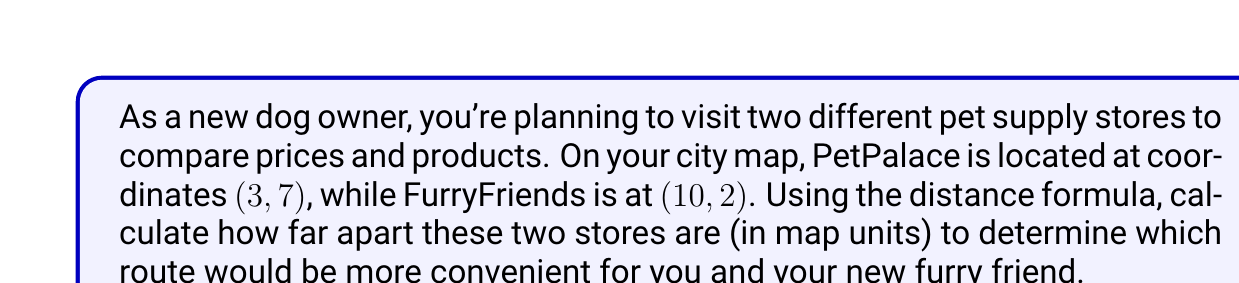Show me your answer to this math problem. To solve this problem, we'll use the distance formula, which is derived from the Pythagorean theorem. The distance formula for two points $(x_1, y_1)$ and $(x_2, y_2)$ is:

$$d = \sqrt{(x_2 - x_1)^2 + (y_2 - y_1)^2}$$

Let's follow these steps:

1. Identify the coordinates:
   PetPalace: $(x_1, y_1) = (3, 7)$
   FurryFriends: $(x_2, y_2) = (10, 2)$

2. Substitute these values into the distance formula:
   $$d = \sqrt{(10 - 3)^2 + (2 - 7)^2}$$

3. Simplify the expressions inside the parentheses:
   $$d = \sqrt{7^2 + (-5)^2}$$

4. Calculate the squares:
   $$d = \sqrt{49 + 25}$$

5. Add the values under the square root:
   $$d = \sqrt{74}$$

6. Simplify the square root if possible (in this case, it cannot be simplified further).

The distance between the two pet supply stores is $\sqrt{74}$ map units.

[asy]
unitsize(0.5cm);
dot((3,7));
dot((10,2));
label("PetPalace (3,7)", (3,7), NE);
label("FurryFriends (10,2)", (10,2), SE);
draw((3,7)--(10,2), dashed);
draw((0,0)--(12,0)--(12,8)--(0,8)--cycle);
[/asy]
Answer: $\sqrt{74}$ map units 